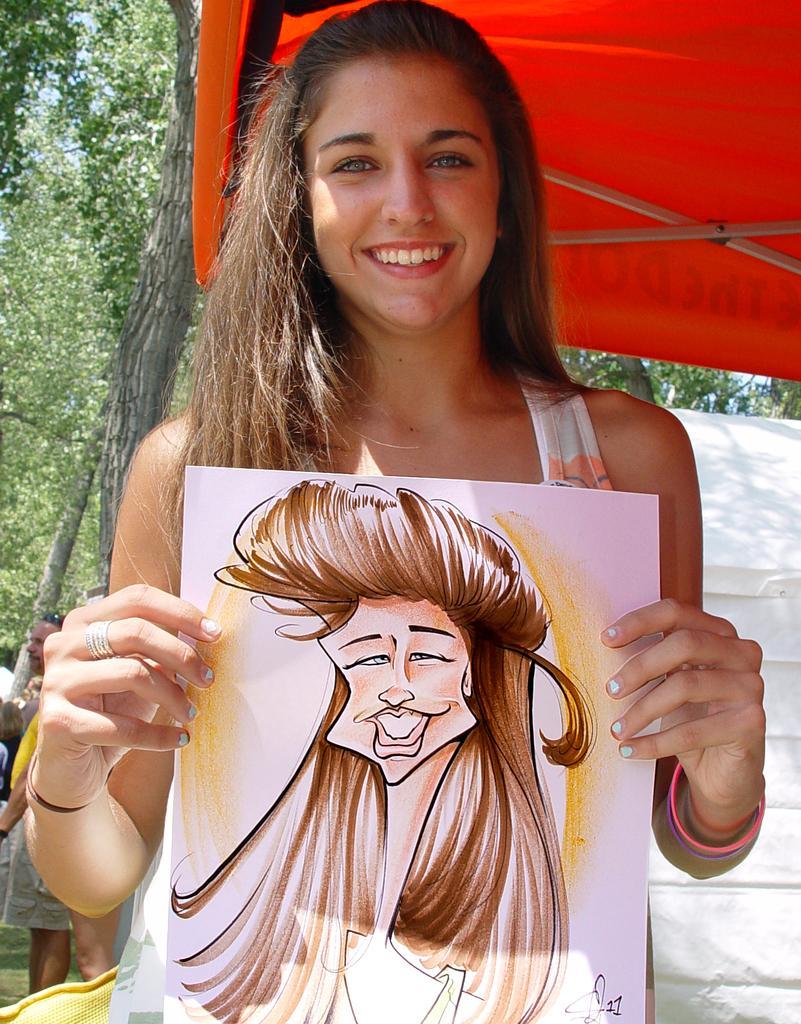In one or two sentences, can you explain what this image depicts? In this image I can see the person standing and holding the board and I can see an art on the board. In the background I can see the tent in orange color and I can see the person standing, few trees in green color and the sky is in blue color. 